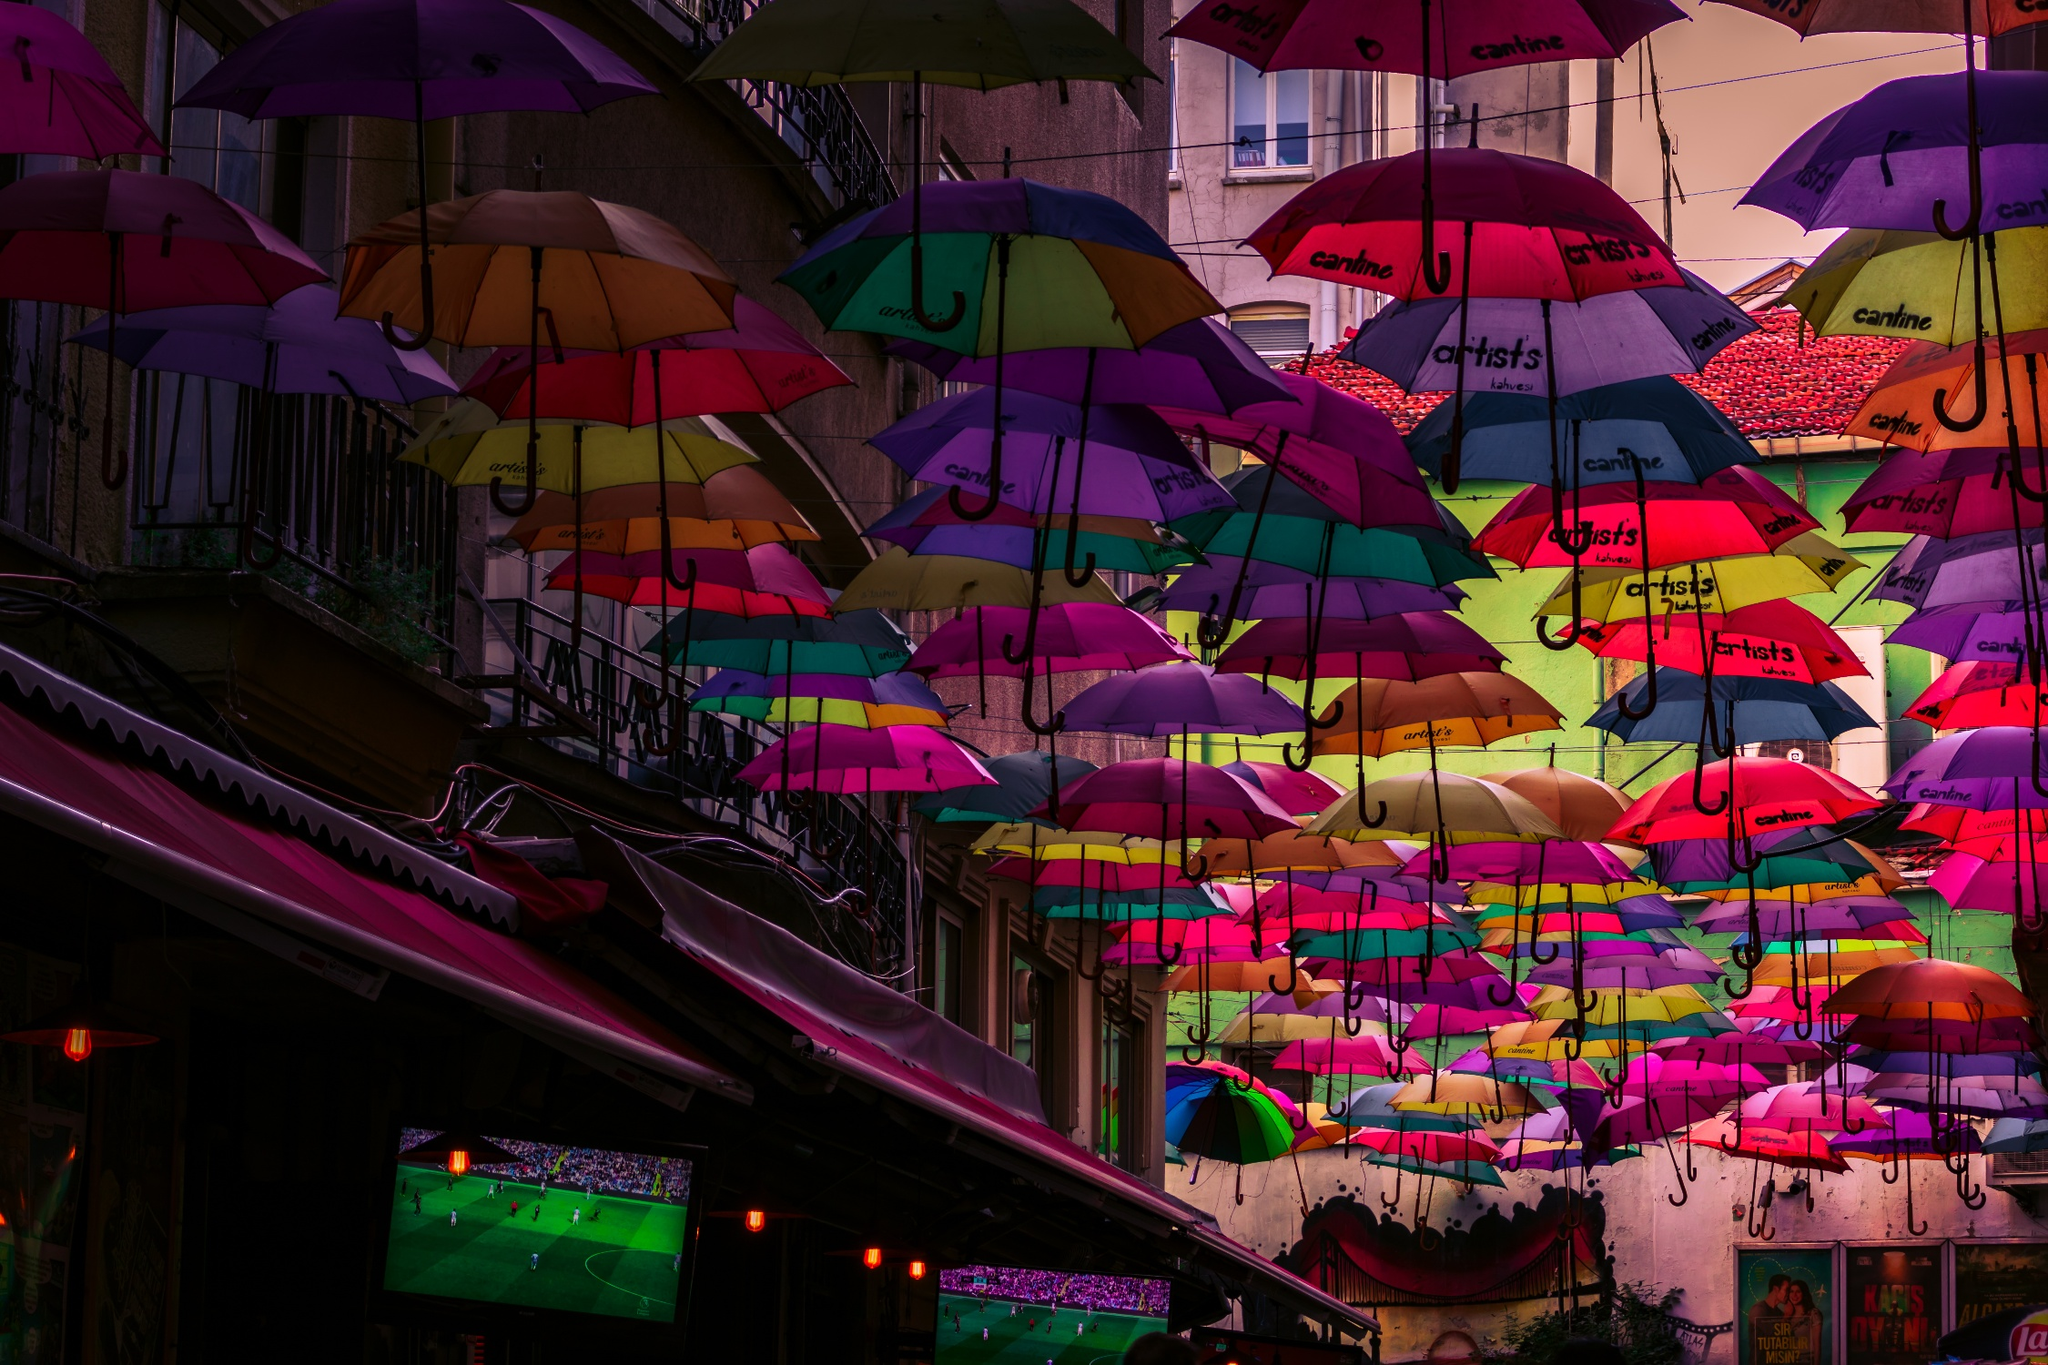What are the key elements in this picture? The image presents a stunning visual arrangement above a street in Portugal, characterized by a canopy of multicolored umbrellas. These umbrellas, each branded with names like 'Carte d'Or', 'Erístoff', and 'Licor Beirão', possibly suggest sponsorship by local businesses or events. Directly underneath, the street life bustles with activity; you can even glimpse a television screen broadcasting a soccer match, adding a layer of local cultural engagement. The buildings flanking the street, with their traditional architecture and vibrant signage for cafes and shops, create a charming and inviting environment. The umbrellas not only provide shade but also transform the space into a lively, artistic corridor, enhancing the street's aesthetic appeal and drawing visitors. 